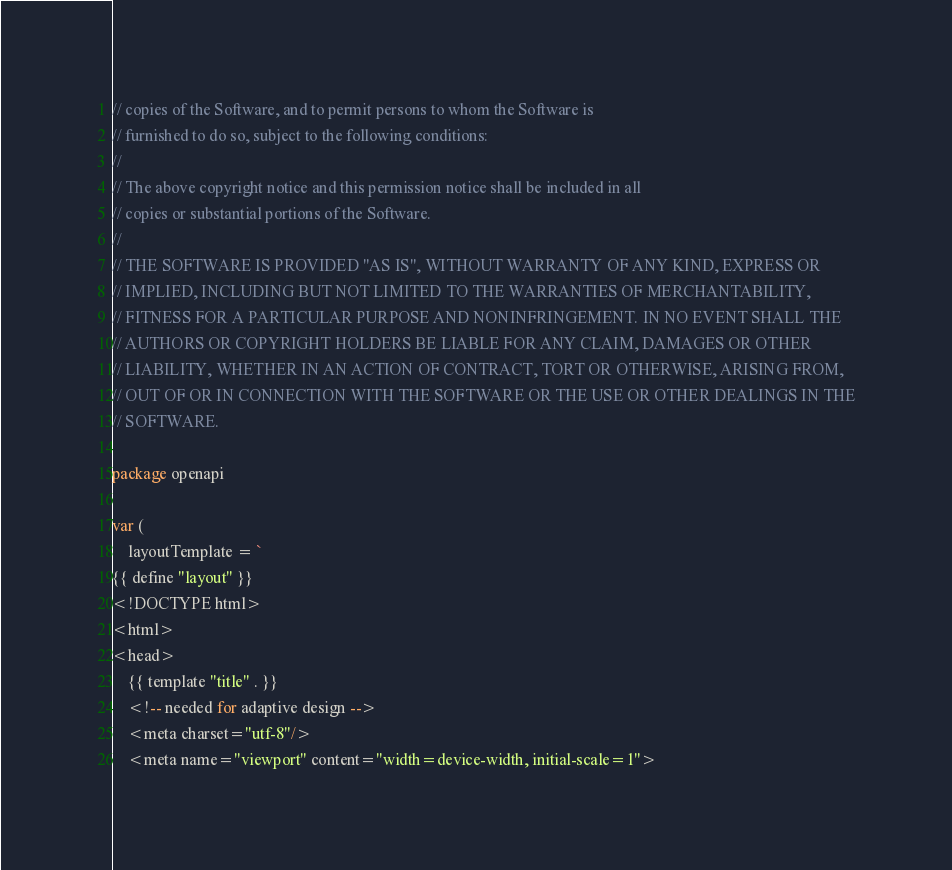<code> <loc_0><loc_0><loc_500><loc_500><_Go_>// copies of the Software, and to permit persons to whom the Software is
// furnished to do so, subject to the following conditions:
//
// The above copyright notice and this permission notice shall be included in all
// copies or substantial portions of the Software.
//
// THE SOFTWARE IS PROVIDED "AS IS", WITHOUT WARRANTY OF ANY KIND, EXPRESS OR
// IMPLIED, INCLUDING BUT NOT LIMITED TO THE WARRANTIES OF MERCHANTABILITY,
// FITNESS FOR A PARTICULAR PURPOSE AND NONINFRINGEMENT. IN NO EVENT SHALL THE
// AUTHORS OR COPYRIGHT HOLDERS BE LIABLE FOR ANY CLAIM, DAMAGES OR OTHER
// LIABILITY, WHETHER IN AN ACTION OF CONTRACT, TORT OR OTHERWISE, ARISING FROM,
// OUT OF OR IN CONNECTION WITH THE SOFTWARE OR THE USE OR OTHER DEALINGS IN THE
// SOFTWARE.

package openapi

var (
	layoutTemplate = `
{{ define "layout" }}
<!DOCTYPE html>
<html>
<head>
    {{ template "title" . }}
    <!-- needed for adaptive design -->
    <meta charset="utf-8"/>
    <meta name="viewport" content="width=device-width, initial-scale=1"></code> 